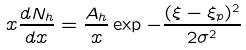Convert formula to latex. <formula><loc_0><loc_0><loc_500><loc_500>x \frac { d N _ { h } } { d x } = \frac { A _ { h } } { x } \exp { - \frac { ( \xi - \xi _ { p } ) ^ { 2 } } { 2 \sigma ^ { 2 } } }</formula> 